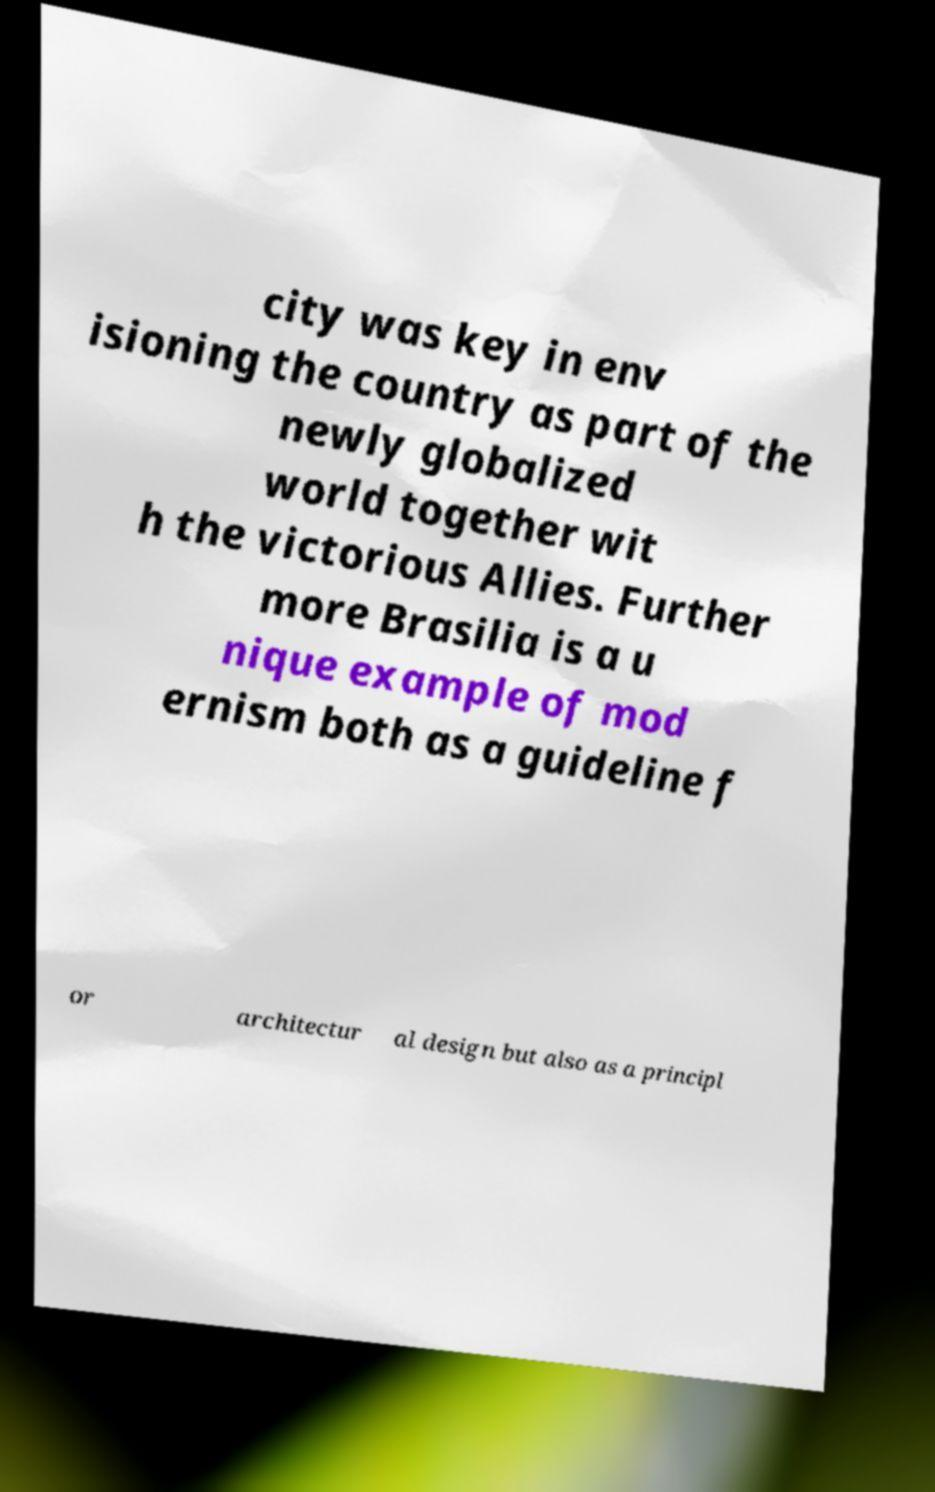Please identify and transcribe the text found in this image. city was key in env isioning the country as part of the newly globalized world together wit h the victorious Allies. Further more Brasilia is a u nique example of mod ernism both as a guideline f or architectur al design but also as a principl 